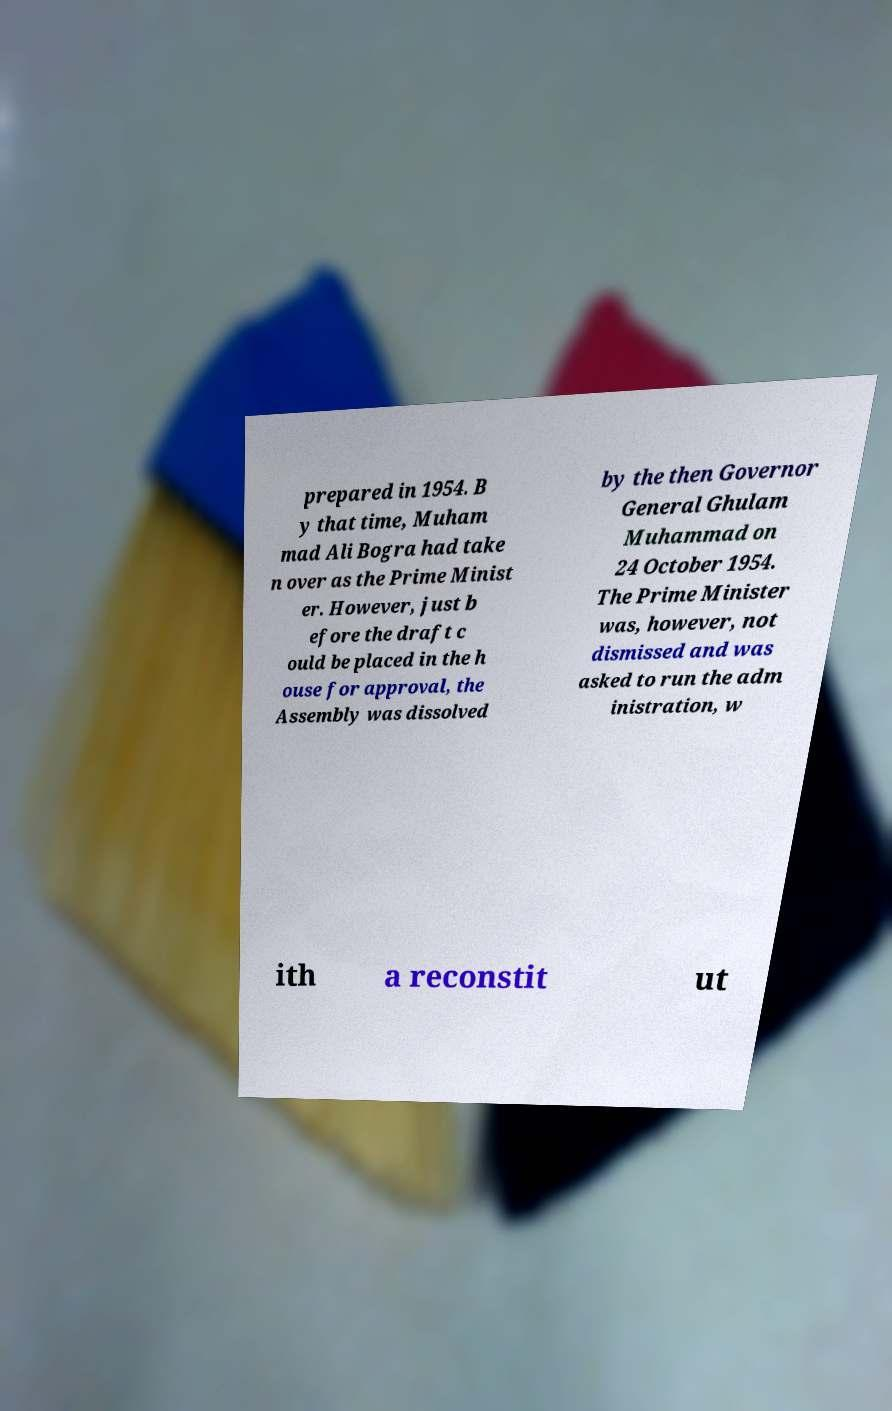Can you read and provide the text displayed in the image?This photo seems to have some interesting text. Can you extract and type it out for me? prepared in 1954. B y that time, Muham mad Ali Bogra had take n over as the Prime Minist er. However, just b efore the draft c ould be placed in the h ouse for approval, the Assembly was dissolved by the then Governor General Ghulam Muhammad on 24 October 1954. The Prime Minister was, however, not dismissed and was asked to run the adm inistration, w ith a reconstit ut 